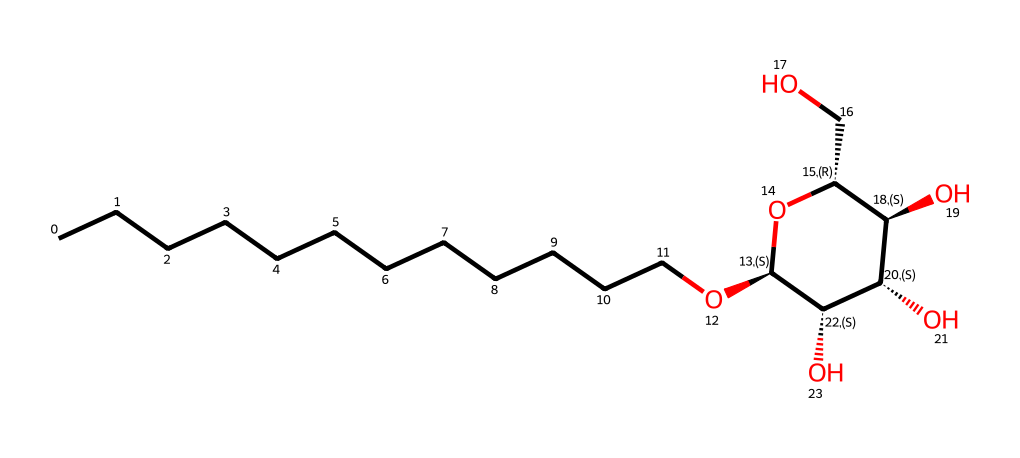What is the main functional group present in this molecule? The molecule contains an ether linkage (C-O-C) as indicated by the oxygen atoms bound between carbon atoms, which shows characteristics of alkyl polyglucosides.
Answer: ether How many carbon atoms are in the longest alkyl chain of the molecule? Upon analyzing the structure, there are 12 carbon atoms in the straight chain of alkyl carbon atoms directly connected to the oxygen.
Answer: 12 What type of surfactant is alkyl polyglucoside considered? Alkyl polyglucosides are classified as non-ionic surfactants due to the lack of ionizable groups in their structure, and they do not carry a charge.
Answer: non-ionic What is the molecular formula derived from the SMILES representation? By counting the atoms in the SMILES, we derive the molecular formula as C12H26O6, representing the alkyl group and the sugar-based structure together.
Answer: C12H26O6 How many hydroxyl groups are present in the molecular structure? Analyzing the structure, three hydroxyl (–OH) groups can be identified, which are crucial for its cleansing properties and solubility in water.
Answer: 3 What characteristic property of surfactants does this molecule demonstrate? The hydrophilic (water-attracting) properties are indicated by the polar hydroxyl groups and sugar part, which allows this compound to reduce surface tension and better interact with water.
Answer: reduces surface tension Which part of the molecule contributes to its eco-friendly aspect? The use of natural, renewable resources like glucose and fatty alcohol from plants in the structure showcases the sustainability and biodegradability of alkyl polyglucosides.
Answer: renewable 